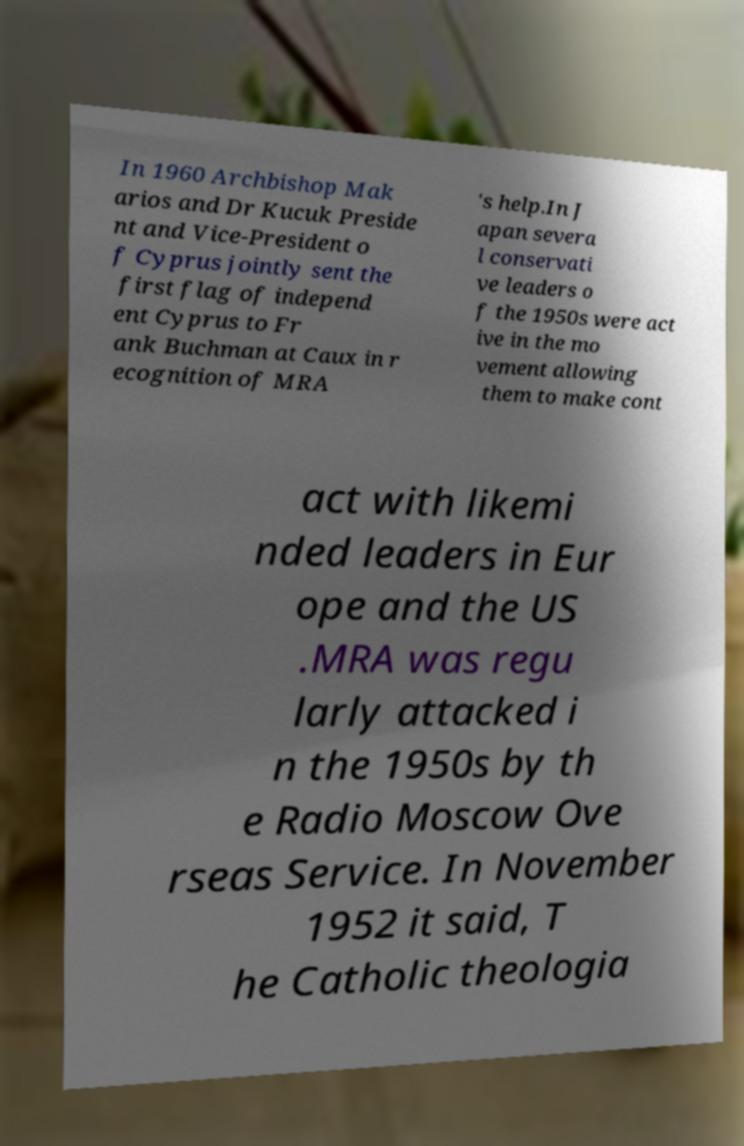Please read and relay the text visible in this image. What does it say? In 1960 Archbishop Mak arios and Dr Kucuk Preside nt and Vice-President o f Cyprus jointly sent the first flag of independ ent Cyprus to Fr ank Buchman at Caux in r ecognition of MRA 's help.In J apan severa l conservati ve leaders o f the 1950s were act ive in the mo vement allowing them to make cont act with likemi nded leaders in Eur ope and the US .MRA was regu larly attacked i n the 1950s by th e Radio Moscow Ove rseas Service. In November 1952 it said, T he Catholic theologia 